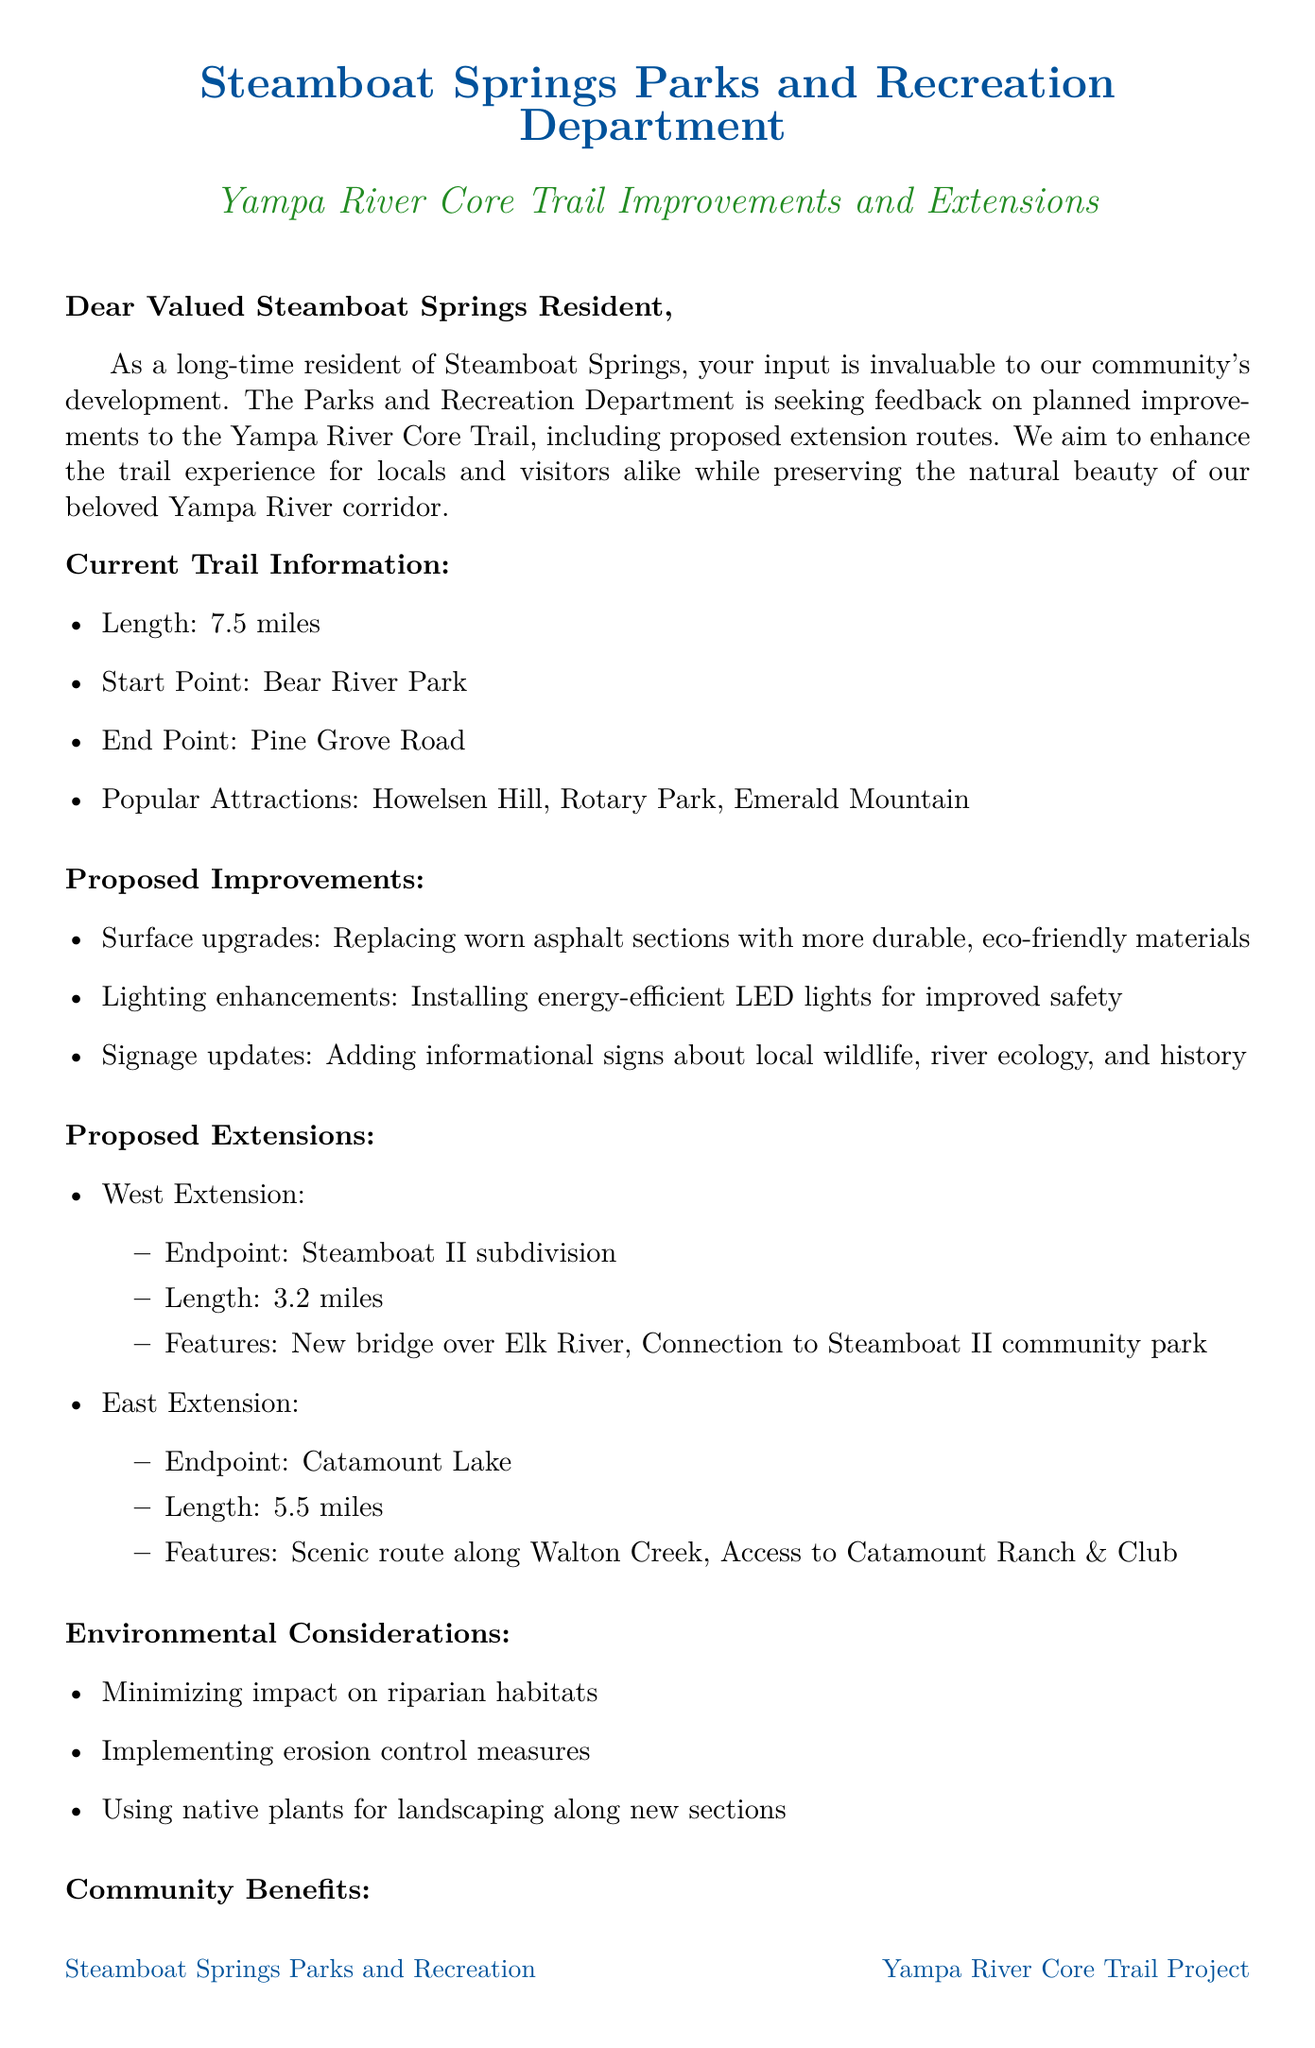What is the length of the Yampa River Core Trail? The length of the Yampa River Core Trail is mentioned as 7.5 miles in the document.
Answer: 7.5 miles Who is the contact person for the Yampa River Core Trail project? The document states that Sarah Johnson is the contact person for the project.
Answer: Sarah Johnson What are the proposed improvements regarding lighting? The document specifies that the lighting enhancements involve installing energy-efficient LED lights for improved safety.
Answer: Energy-efficient LED lights What is the endpoint of the proposed west extension? The endpoint for the west extension is indicated as Steamboat II subdivision in the document.
Answer: Steamboat II subdivision What is the deadline for submitting feedback? The document clearly states that the feedback submission deadline is June 15, 2023.
Answer: June 15, 2023 How frequently do residents use the Yampa River Core Trail? This question is one of the feedback questions asking residents about their usage frequency.
Answer: Frequency of usage (variable answer) What community benefits are mentioned in the document? The document lists multiple community benefits, including increased connectivity between neighborhoods.
Answer: Increased connectivity between neighborhoods What is one of the environmental considerations for the improvements? The document mentions minimizing impact on riparian habitats as an environmental consideration.
Answer: Minimizing impact on riparian habitats What is the start point of the current trail? According to the document, Bear River Park is the start point of the current trail.
Answer: Bear River Park 